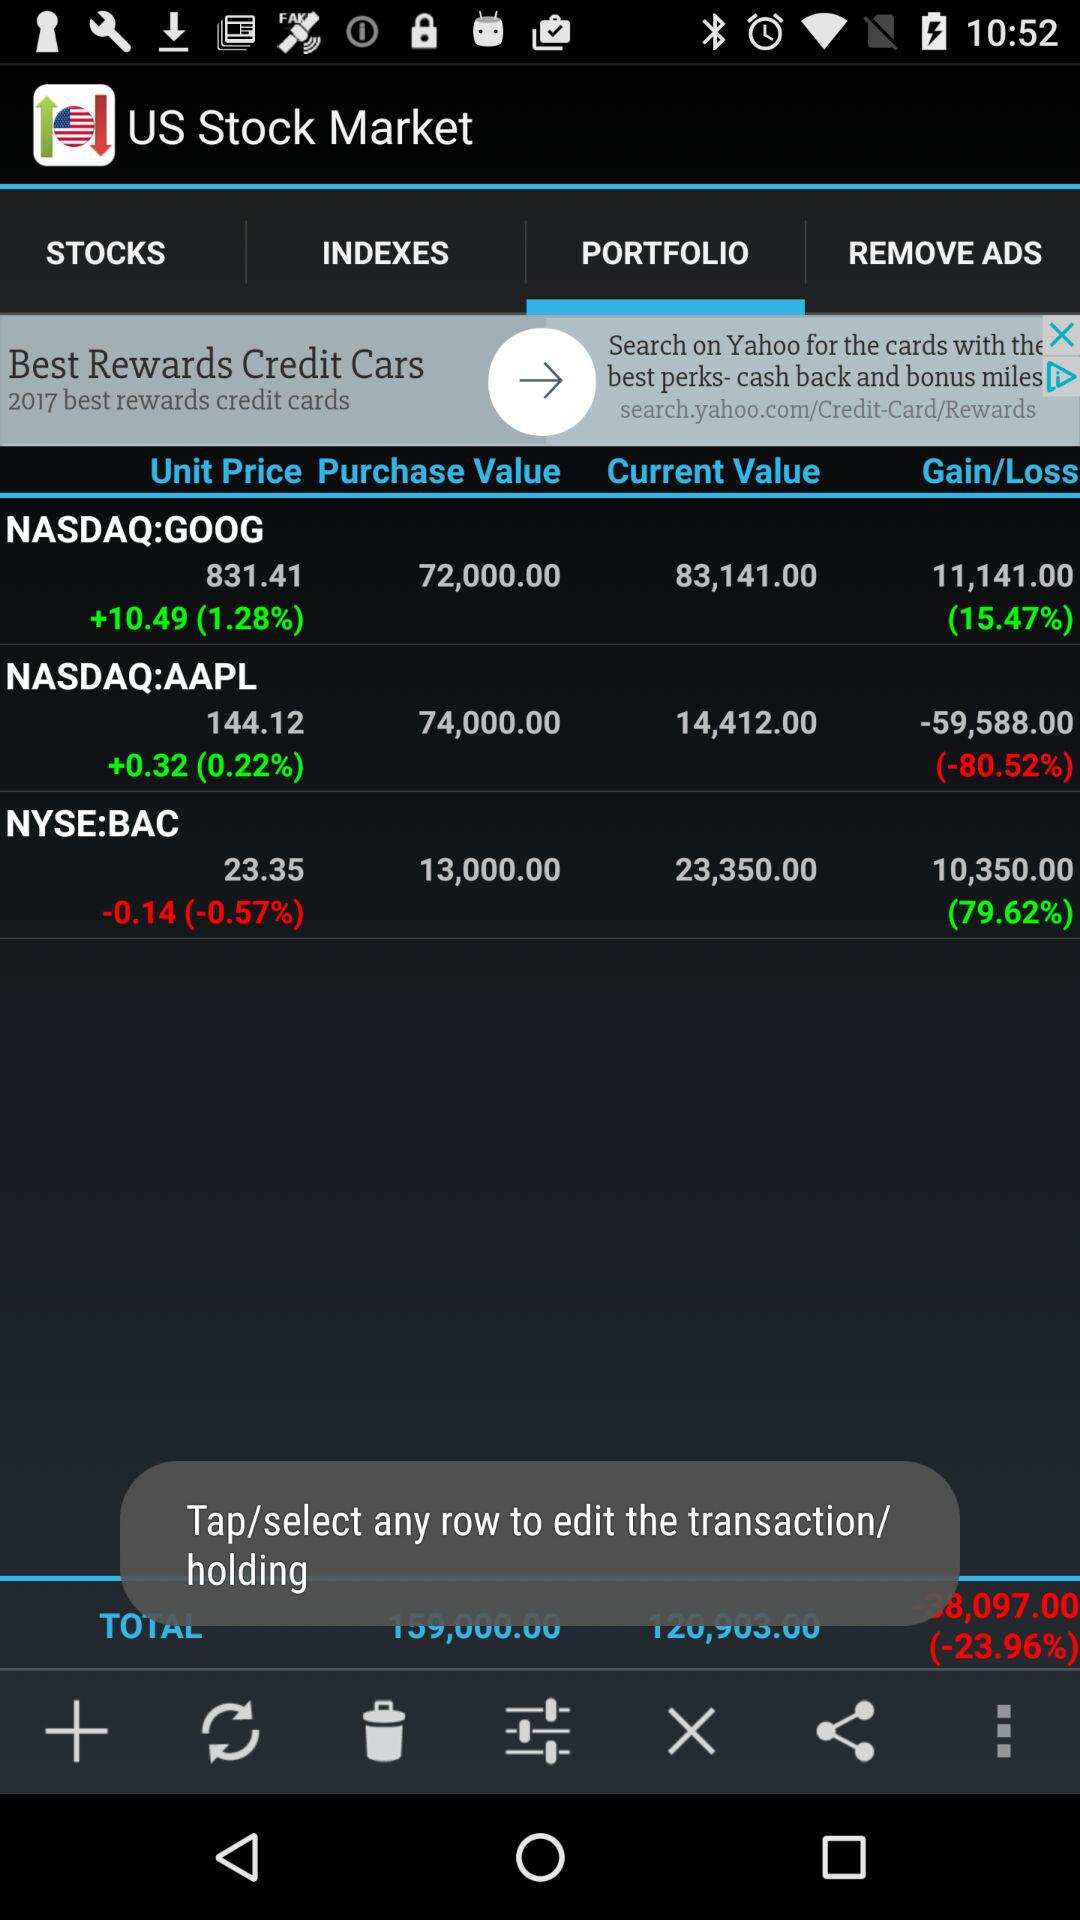What is the selected option in the "US Stock Market"? The selected option is "PORTFOLIO". 